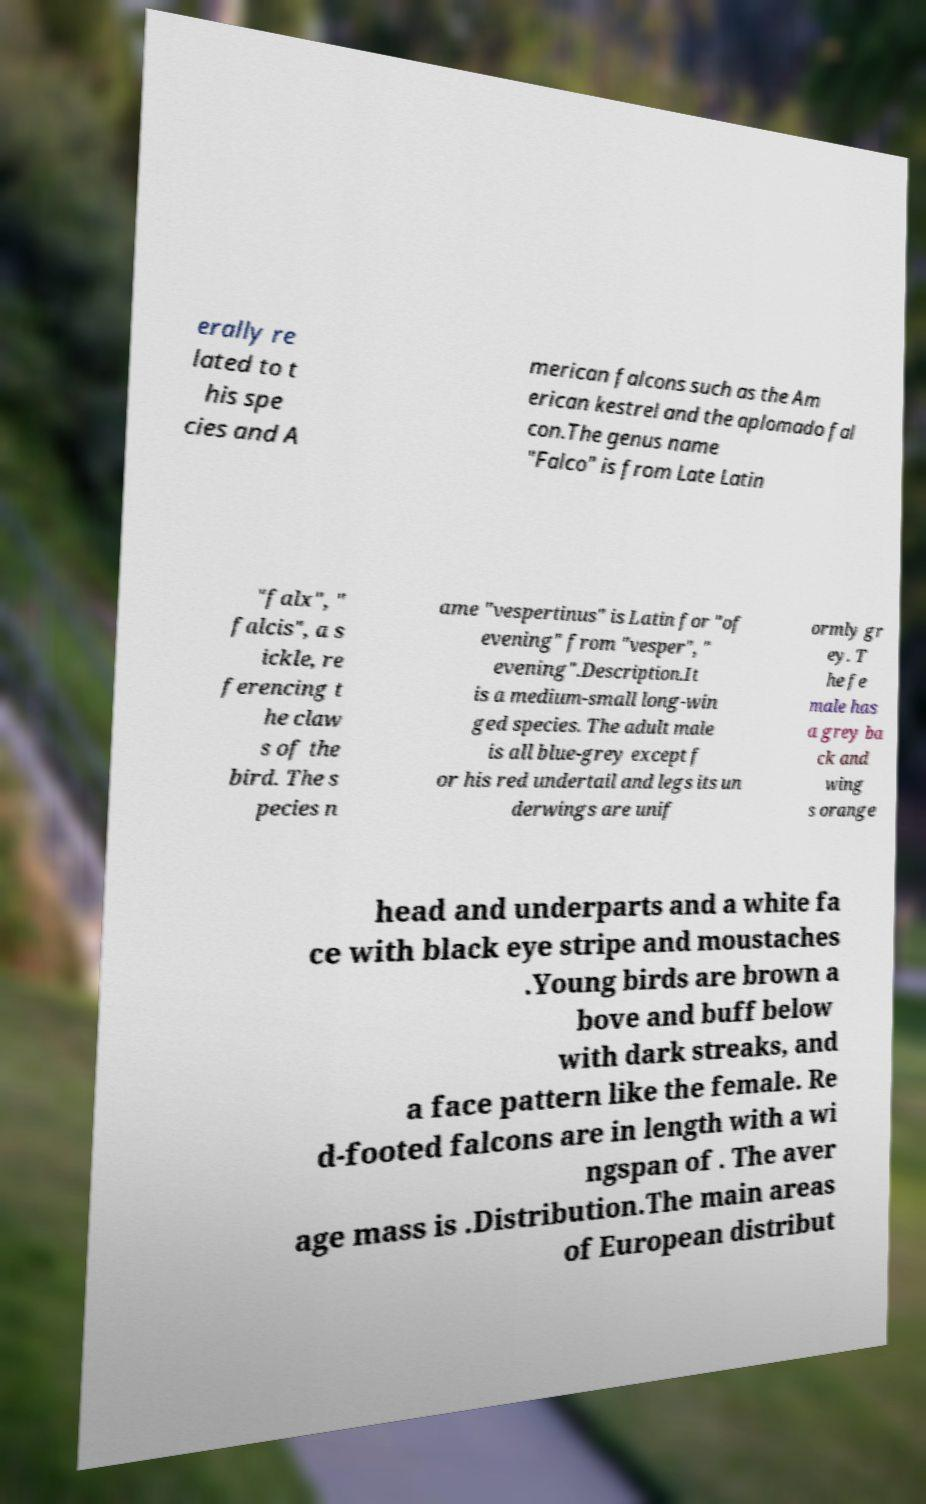Please read and relay the text visible in this image. What does it say? erally re lated to t his spe cies and A merican falcons such as the Am erican kestrel and the aplomado fal con.The genus name "Falco" is from Late Latin "falx", " falcis", a s ickle, re ferencing t he claw s of the bird. The s pecies n ame "vespertinus" is Latin for "of evening" from "vesper", " evening".Description.It is a medium-small long-win ged species. The adult male is all blue-grey except f or his red undertail and legs its un derwings are unif ormly gr ey. T he fe male has a grey ba ck and wing s orange head and underparts and a white fa ce with black eye stripe and moustaches .Young birds are brown a bove and buff below with dark streaks, and a face pattern like the female. Re d-footed falcons are in length with a wi ngspan of . The aver age mass is .Distribution.The main areas of European distribut 